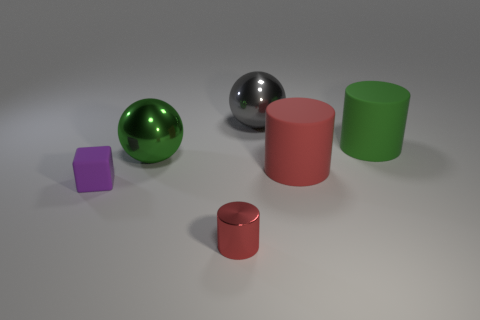There is a green sphere; what number of large green cylinders are to the left of it?
Your response must be concise. 0. There is a green thing that is the same shape as the gray object; what size is it?
Keep it short and to the point. Large. What is the size of the object that is left of the big green rubber thing and behind the big green metal sphere?
Offer a very short reply. Large. Does the shiny cylinder have the same color as the matte object on the left side of the large gray shiny ball?
Provide a short and direct response. No. What number of gray things are either tiny metallic objects or big cylinders?
Ensure brevity in your answer.  0. What is the shape of the small purple matte thing?
Make the answer very short. Cube. How many other things are the same shape as the green shiny object?
Make the answer very short. 1. There is a shiny sphere behind the green cylinder; what is its color?
Keep it short and to the point. Gray. Do the large red cylinder and the green cylinder have the same material?
Your answer should be compact. Yes. How many things are big blue matte things or objects that are left of the tiny red shiny cylinder?
Make the answer very short. 2. 